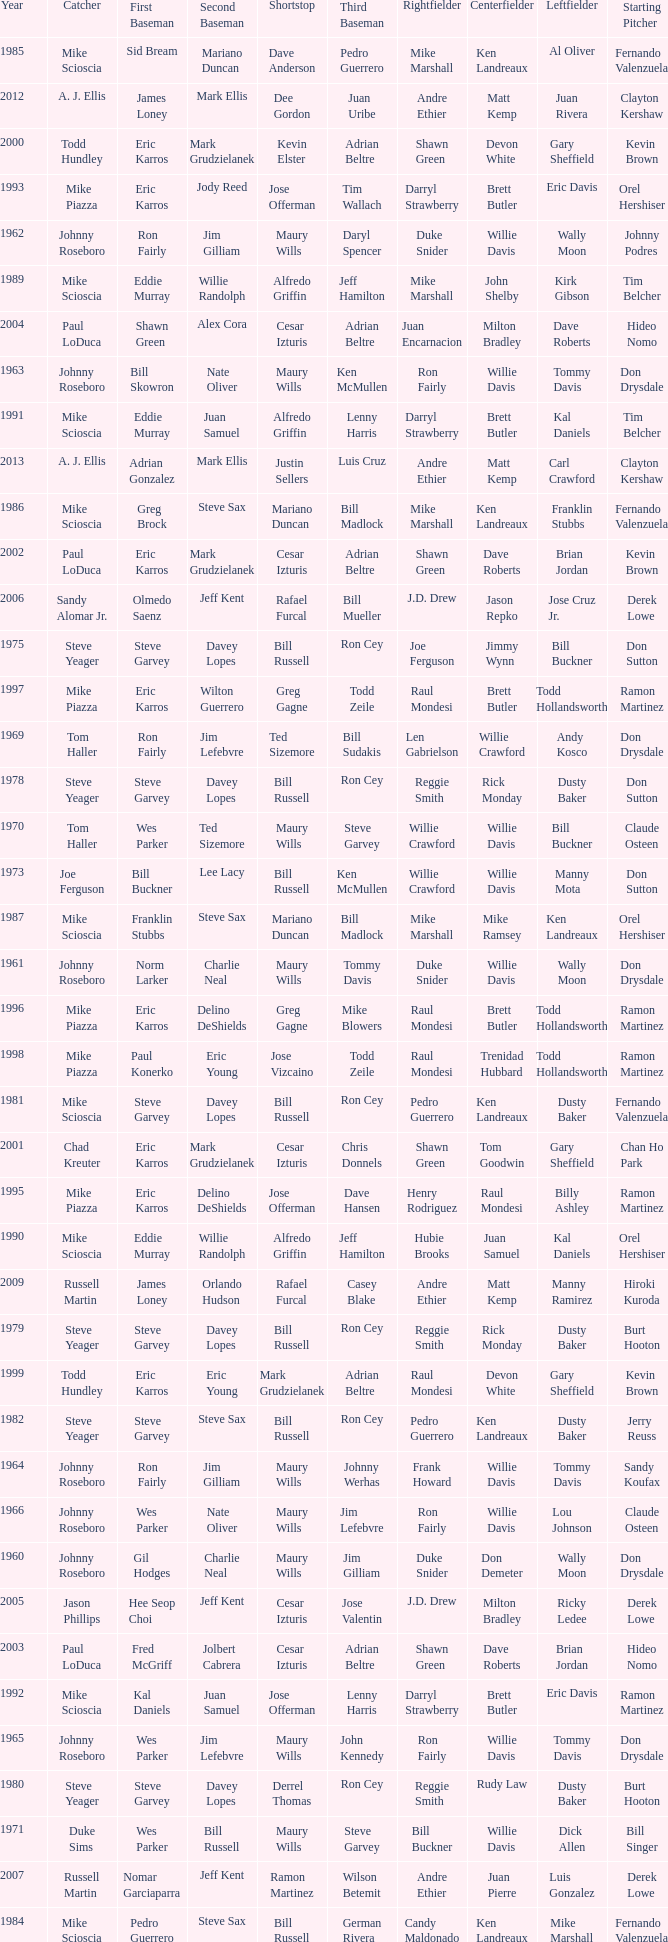Who played SS when paul konerko played 1st base? Jose Vizcaino. Would you mind parsing the complete table? {'header': ['Year', 'Catcher', 'First Baseman', 'Second Baseman', 'Shortstop', 'Third Baseman', 'Rightfielder', 'Centerfielder', 'Leftfielder', 'Starting Pitcher'], 'rows': [['1985', 'Mike Scioscia', 'Sid Bream', 'Mariano Duncan', 'Dave Anderson', 'Pedro Guerrero', 'Mike Marshall', 'Ken Landreaux', 'Al Oliver', 'Fernando Valenzuela'], ['2012', 'A. J. Ellis', 'James Loney', 'Mark Ellis', 'Dee Gordon', 'Juan Uribe', 'Andre Ethier', 'Matt Kemp', 'Juan Rivera', 'Clayton Kershaw'], ['2000', 'Todd Hundley', 'Eric Karros', 'Mark Grudzielanek', 'Kevin Elster', 'Adrian Beltre', 'Shawn Green', 'Devon White', 'Gary Sheffield', 'Kevin Brown'], ['1993', 'Mike Piazza', 'Eric Karros', 'Jody Reed', 'Jose Offerman', 'Tim Wallach', 'Darryl Strawberry', 'Brett Butler', 'Eric Davis', 'Orel Hershiser'], ['1962', 'Johnny Roseboro', 'Ron Fairly', 'Jim Gilliam', 'Maury Wills', 'Daryl Spencer', 'Duke Snider', 'Willie Davis', 'Wally Moon', 'Johnny Podres'], ['1989', 'Mike Scioscia', 'Eddie Murray', 'Willie Randolph', 'Alfredo Griffin', 'Jeff Hamilton', 'Mike Marshall', 'John Shelby', 'Kirk Gibson', 'Tim Belcher'], ['2004', 'Paul LoDuca', 'Shawn Green', 'Alex Cora', 'Cesar Izturis', 'Adrian Beltre', 'Juan Encarnacion', 'Milton Bradley', 'Dave Roberts', 'Hideo Nomo'], ['1963', 'Johnny Roseboro', 'Bill Skowron', 'Nate Oliver', 'Maury Wills', 'Ken McMullen', 'Ron Fairly', 'Willie Davis', 'Tommy Davis', 'Don Drysdale'], ['1991', 'Mike Scioscia', 'Eddie Murray', 'Juan Samuel', 'Alfredo Griffin', 'Lenny Harris', 'Darryl Strawberry', 'Brett Butler', 'Kal Daniels', 'Tim Belcher'], ['2013', 'A. J. Ellis', 'Adrian Gonzalez', 'Mark Ellis', 'Justin Sellers', 'Luis Cruz', 'Andre Ethier', 'Matt Kemp', 'Carl Crawford', 'Clayton Kershaw'], ['1986', 'Mike Scioscia', 'Greg Brock', 'Steve Sax', 'Mariano Duncan', 'Bill Madlock', 'Mike Marshall', 'Ken Landreaux', 'Franklin Stubbs', 'Fernando Valenzuela'], ['2002', 'Paul LoDuca', 'Eric Karros', 'Mark Grudzielanek', 'Cesar Izturis', 'Adrian Beltre', 'Shawn Green', 'Dave Roberts', 'Brian Jordan', 'Kevin Brown'], ['2006', 'Sandy Alomar Jr.', 'Olmedo Saenz', 'Jeff Kent', 'Rafael Furcal', 'Bill Mueller', 'J.D. Drew', 'Jason Repko', 'Jose Cruz Jr.', 'Derek Lowe'], ['1975', 'Steve Yeager', 'Steve Garvey', 'Davey Lopes', 'Bill Russell', 'Ron Cey', 'Joe Ferguson', 'Jimmy Wynn', 'Bill Buckner', 'Don Sutton'], ['1997', 'Mike Piazza', 'Eric Karros', 'Wilton Guerrero', 'Greg Gagne', 'Todd Zeile', 'Raul Mondesi', 'Brett Butler', 'Todd Hollandsworth', 'Ramon Martinez'], ['1969', 'Tom Haller', 'Ron Fairly', 'Jim Lefebvre', 'Ted Sizemore', 'Bill Sudakis', 'Len Gabrielson', 'Willie Crawford', 'Andy Kosco', 'Don Drysdale'], ['1978', 'Steve Yeager', 'Steve Garvey', 'Davey Lopes', 'Bill Russell', 'Ron Cey', 'Reggie Smith', 'Rick Monday', 'Dusty Baker', 'Don Sutton'], ['1970', 'Tom Haller', 'Wes Parker', 'Ted Sizemore', 'Maury Wills', 'Steve Garvey', 'Willie Crawford', 'Willie Davis', 'Bill Buckner', 'Claude Osteen'], ['1973', 'Joe Ferguson', 'Bill Buckner', 'Lee Lacy', 'Bill Russell', 'Ken McMullen', 'Willie Crawford', 'Willie Davis', 'Manny Mota', 'Don Sutton'], ['1987', 'Mike Scioscia', 'Franklin Stubbs', 'Steve Sax', 'Mariano Duncan', 'Bill Madlock', 'Mike Marshall', 'Mike Ramsey', 'Ken Landreaux', 'Orel Hershiser'], ['1961', 'Johnny Roseboro', 'Norm Larker', 'Charlie Neal', 'Maury Wills', 'Tommy Davis', 'Duke Snider', 'Willie Davis', 'Wally Moon', 'Don Drysdale'], ['1996', 'Mike Piazza', 'Eric Karros', 'Delino DeShields', 'Greg Gagne', 'Mike Blowers', 'Raul Mondesi', 'Brett Butler', 'Todd Hollandsworth', 'Ramon Martinez'], ['1998', 'Mike Piazza', 'Paul Konerko', 'Eric Young', 'Jose Vizcaino', 'Todd Zeile', 'Raul Mondesi', 'Trenidad Hubbard', 'Todd Hollandsworth', 'Ramon Martinez'], ['1981', 'Mike Scioscia', 'Steve Garvey', 'Davey Lopes', 'Bill Russell', 'Ron Cey', 'Pedro Guerrero', 'Ken Landreaux', 'Dusty Baker', 'Fernando Valenzuela'], ['2001', 'Chad Kreuter', 'Eric Karros', 'Mark Grudzielanek', 'Cesar Izturis', 'Chris Donnels', 'Shawn Green', 'Tom Goodwin', 'Gary Sheffield', 'Chan Ho Park'], ['1995', 'Mike Piazza', 'Eric Karros', 'Delino DeShields', 'Jose Offerman', 'Dave Hansen', 'Henry Rodriguez', 'Raul Mondesi', 'Billy Ashley', 'Ramon Martinez'], ['1990', 'Mike Scioscia', 'Eddie Murray', 'Willie Randolph', 'Alfredo Griffin', 'Jeff Hamilton', 'Hubie Brooks', 'Juan Samuel', 'Kal Daniels', 'Orel Hershiser'], ['2009', 'Russell Martin', 'James Loney', 'Orlando Hudson', 'Rafael Furcal', 'Casey Blake', 'Andre Ethier', 'Matt Kemp', 'Manny Ramirez', 'Hiroki Kuroda'], ['1979', 'Steve Yeager', 'Steve Garvey', 'Davey Lopes', 'Bill Russell', 'Ron Cey', 'Reggie Smith', 'Rick Monday', 'Dusty Baker', 'Burt Hooton'], ['1999', 'Todd Hundley', 'Eric Karros', 'Eric Young', 'Mark Grudzielanek', 'Adrian Beltre', 'Raul Mondesi', 'Devon White', 'Gary Sheffield', 'Kevin Brown'], ['1982', 'Steve Yeager', 'Steve Garvey', 'Steve Sax', 'Bill Russell', 'Ron Cey', 'Pedro Guerrero', 'Ken Landreaux', 'Dusty Baker', 'Jerry Reuss'], ['1964', 'Johnny Roseboro', 'Ron Fairly', 'Jim Gilliam', 'Maury Wills', 'Johnny Werhas', 'Frank Howard', 'Willie Davis', 'Tommy Davis', 'Sandy Koufax'], ['1966', 'Johnny Roseboro', 'Wes Parker', 'Nate Oliver', 'Maury Wills', 'Jim Lefebvre', 'Ron Fairly', 'Willie Davis', 'Lou Johnson', 'Claude Osteen'], ['1960', 'Johnny Roseboro', 'Gil Hodges', 'Charlie Neal', 'Maury Wills', 'Jim Gilliam', 'Duke Snider', 'Don Demeter', 'Wally Moon', 'Don Drysdale'], ['2005', 'Jason Phillips', 'Hee Seop Choi', 'Jeff Kent', 'Cesar Izturis', 'Jose Valentin', 'J.D. Drew', 'Milton Bradley', 'Ricky Ledee', 'Derek Lowe'], ['2003', 'Paul LoDuca', 'Fred McGriff', 'Jolbert Cabrera', 'Cesar Izturis', 'Adrian Beltre', 'Shawn Green', 'Dave Roberts', 'Brian Jordan', 'Hideo Nomo'], ['1992', 'Mike Scioscia', 'Kal Daniels', 'Juan Samuel', 'Jose Offerman', 'Lenny Harris', 'Darryl Strawberry', 'Brett Butler', 'Eric Davis', 'Ramon Martinez'], ['1965', 'Johnny Roseboro', 'Wes Parker', 'Jim Lefebvre', 'Maury Wills', 'John Kennedy', 'Ron Fairly', 'Willie Davis', 'Tommy Davis', 'Don Drysdale'], ['1980', 'Steve Yeager', 'Steve Garvey', 'Davey Lopes', 'Derrel Thomas', 'Ron Cey', 'Reggie Smith', 'Rudy Law', 'Dusty Baker', 'Burt Hooton'], ['1971', 'Duke Sims', 'Wes Parker', 'Bill Russell', 'Maury Wills', 'Steve Garvey', 'Bill Buckner', 'Willie Davis', 'Dick Allen', 'Bill Singer'], ['2007', 'Russell Martin', 'Nomar Garciaparra', 'Jeff Kent', 'Ramon Martinez', 'Wilson Betemit', 'Andre Ethier', 'Juan Pierre', 'Luis Gonzalez', 'Derek Lowe'], ['1984', 'Mike Scioscia', 'Pedro Guerrero', 'Steve Sax', 'Bill Russell', 'German Rivera', 'Candy Maldonado', 'Ken Landreaux', 'Mike Marshall', 'Fernando Valenzuela'], ['2011', 'Rod Barajas', 'James Loney', 'Jamey Carroll', 'Rafael Furcal', 'Juan Uribe', 'Andre Ethier', 'Matt Kemp', 'Tony Gwynn, Jr.', 'Clayton Kershaw'], ['1976', 'Steve Yeager', 'Steve Garvey', 'Ted Sizemore', 'Bill Russell', 'Ron Cey', 'Joe Ferguson', 'Dusty Baker', 'Bill Buckner', 'Don Sutton'], ['1967', 'Johnny Roseboro', 'Ron Fairly', 'Ron Hunt', 'Gene Michael', 'Jim Lefebvre', 'Lou Johnson', 'Wes Parker', 'Bob Bailey', 'Bob Miller'], ['2010', 'Russell Martin', 'James Loney', 'Blake DeWitt', 'Rafael Furcal', 'Casey Blake', 'Andre Ethier', 'Matt Kemp', 'Manny Ramirez', 'Vicente Padilla'], ['1988', 'Mike Scioscia', 'Mike Marshall', 'Steve Sax', 'Alfredo Griffin', 'Pedro Guerrero', 'Mike Davis', 'John Shelby', 'Kirk Gibson', 'Fernando Valenzuela'], ['1972', 'Duke Sims', 'Bill Buckner', 'Jim Lefebvre', 'Maury Wills', 'Billy Grabarkewitz', 'Frank Robinson', 'Willie Davis', 'Willie Crawford', 'Don Sutton'], ['2008', 'Russell Martin', 'James Loney', 'Jeff Kent', 'Rafael Furcal', 'Blake DeWitt', 'Matt Kemp', 'Andruw Jones', 'Andre Ethier', 'Brad Penny'], ['1977', 'Steve Yeager', 'Steve Garvey', 'Davey Lopes', 'Bill Russell', 'Ron Cey', 'Reggie Smith', 'Rick Monday', 'Dusty Baker', 'Don Sutton'], ['1974', 'Joe Ferguson', 'Bill Buckner', 'Davey Lopes', 'Bill Russell', 'Ron Cey', 'Willie Crawford', 'Jimmy Wynn', 'Von Joshua', 'Don Sutton'], ['1983', 'Steve Yeager', 'Greg Brock', 'Steve Sax', 'Bill Russell', 'Pedro Guerrero', 'Mike Marshall', 'Ken Landreaux', 'Dusty Baker', 'Fernando Valenzuela'], ['1994', 'Mike Piazza', 'Eric Karros', 'Delino DeShields', 'Jose Offerman', 'Tim Wallach', 'Raul Mondesi', 'Brett Butler', 'Henry Rodriguez', 'Orel Hershiser'], ['1968', 'Tom Haller', 'Wes Parker', 'Paul Popovich', 'Zoilo Versalles', 'Bob Bailey', 'Ron Fairly', 'Willie Davis', 'Al Ferrara', 'Claude Osteen'], ['1959', 'Johnny Roseboro', 'Gil Hodges', 'Charlie Neal', 'Don Zimmer', 'Jim Baxes', 'Ron Fairly', 'Duke Snider', 'Wally Moon', 'Don Drysdale']]} 